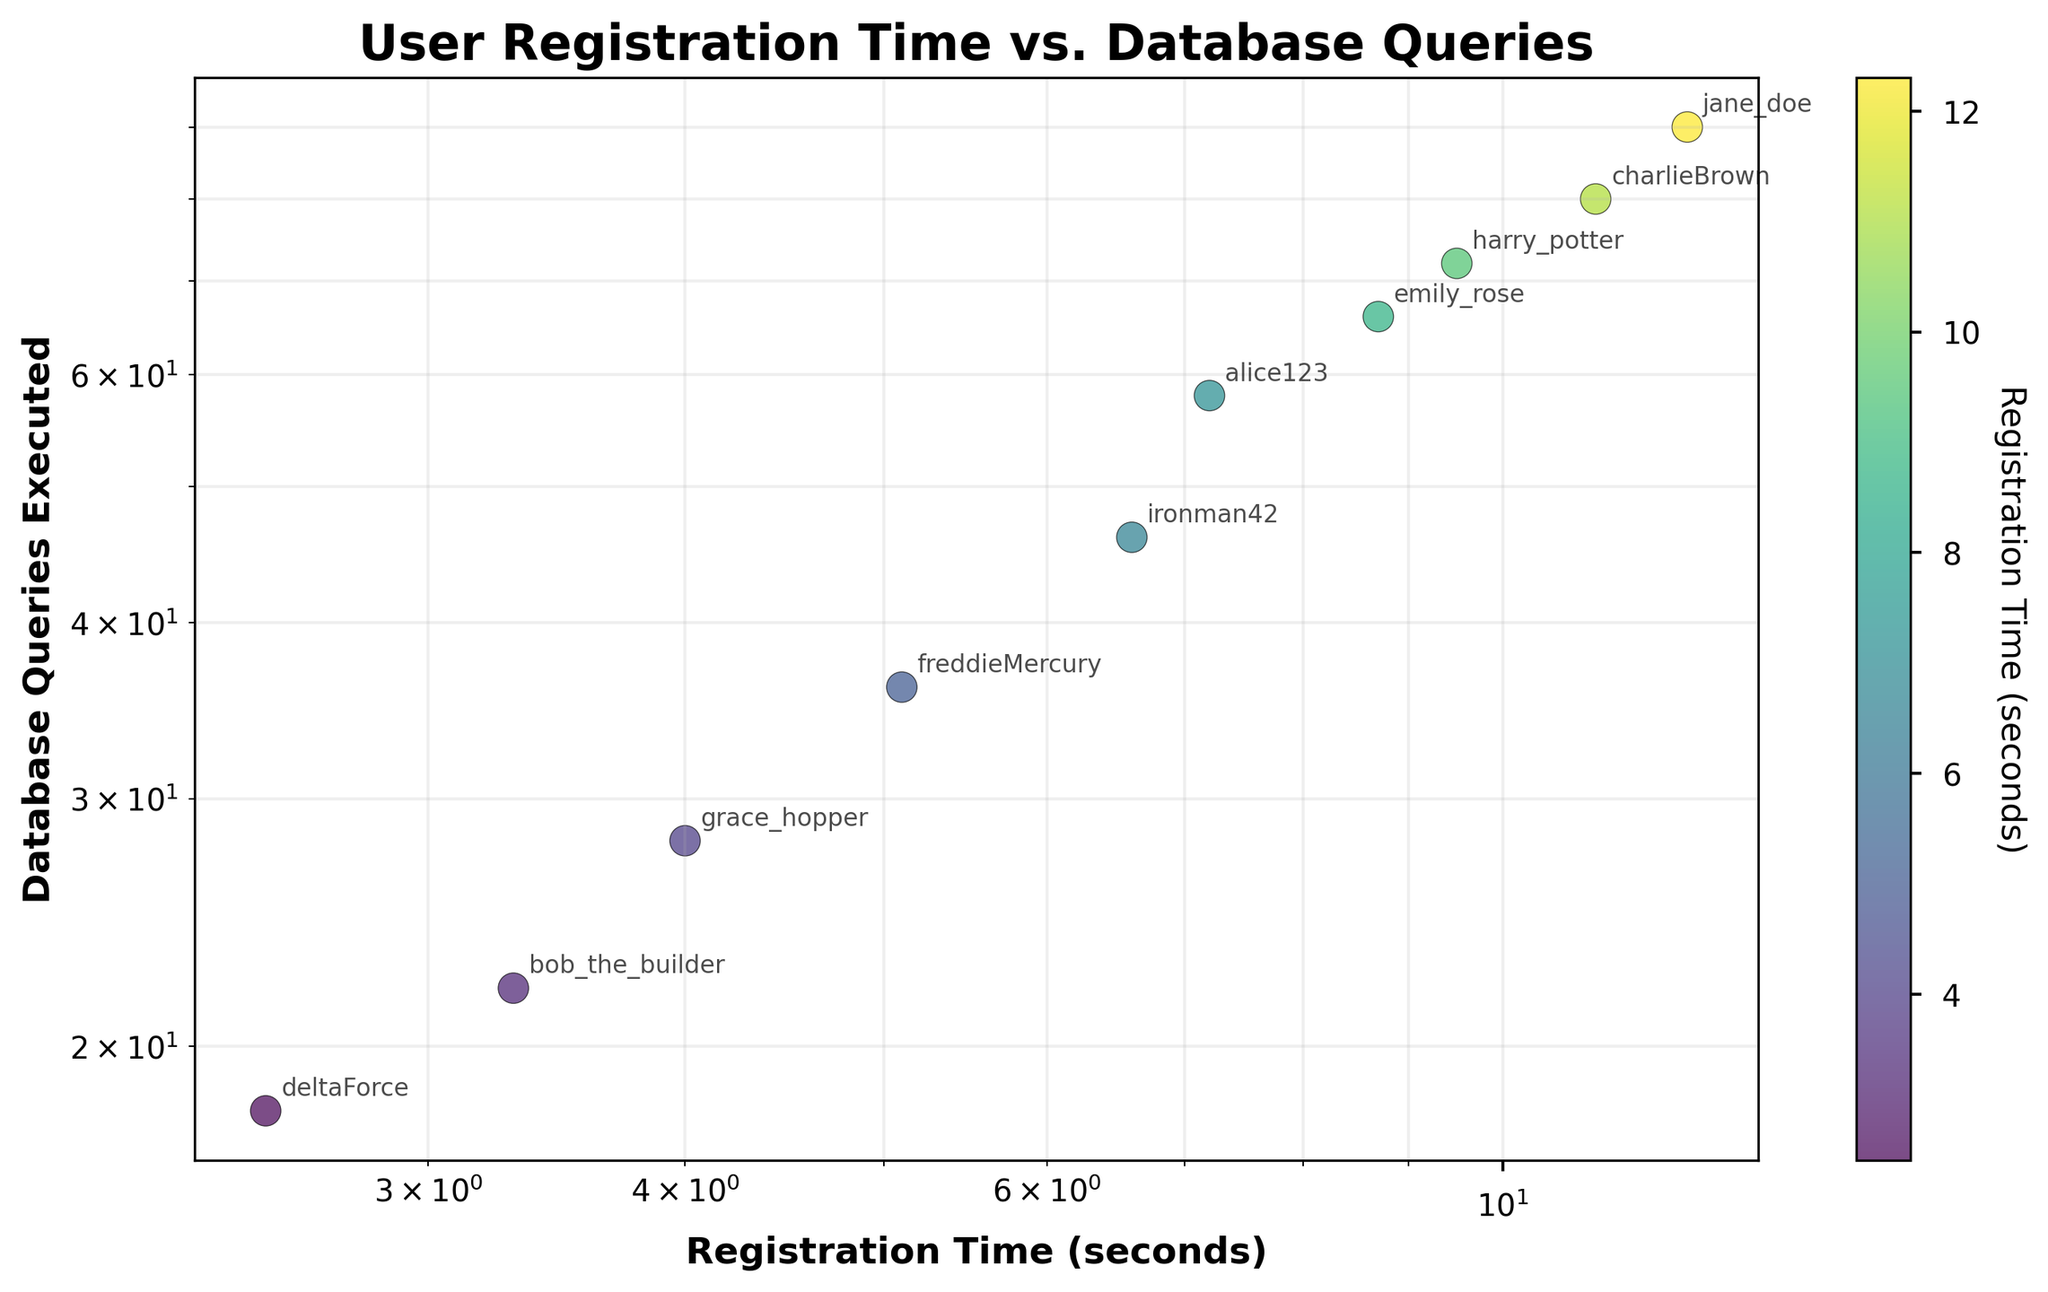What is the title of the plot? The title of the plot is usually displayed at the top center and provides a brief description of what the plot is about. In this figure, the title is directly related to the data being visualized.
Answer: User Registration Time vs. Database Queries How many data points are represented in the plot? Each data point corresponds to a user, and we can count the number of points displayed on the scatter plot to determine the total number of data points. Observing the plot, we count the total number of annotated usernames.
Answer: 10 How is the color of data points determined? The color of the data points is determined by the "Registration Time (seconds)", with a color bar indicating this on the side of the plot. Each point's color represents its registration time.
Answer: Registration Time (seconds) Which user has executed the most database queries? By looking at the vertical axis representing "Database Queries Executed" and identifying the point with the highest position, we can determine which user has executed the most queries. Observing the plot, this user is annotated.
Answer: jane_doe What is the range of registration times shown on the x-axis? The x-axis represents "Registration Time (seconds)" on a logarithmic scale. By examining the plot, especially the x-axis scale, we can determine the minimum and maximum values.
Answer: 2.5 to 12.3 seconds Compare the users "bob_the_builder" and "deltaForce" in terms of database queries executed. Which one has more queries? To find the user with more database queries, compare their vertical positions. "bob_the_builder" is at a higher position on the y-axis than "deltaForce".
Answer: bob_the_builder What is the average number of database queries executed by all users? We need to sum the database queries of all users and divide by the total number of users. Observing the y-values for each point: (58 + 22 + 80 + 18 + 66 + 36 + 28 + 72 + 46 + 90) / 10.
Answer: 51.6 Is there a correlation between registration time and the number of database queries executed? By observing the overall trend in the scatter plot, we can determine if there is a positive or negative correlation, or no correlation. A general visual examination can help identify the trend.
Answer: Positive correlation Which user has the shortest registration time? By looking at the horizontal axis representing "Registration Time (seconds)" and identifying the point closest to the leftmost side, this user's annotation can be read.
Answer: deltaForce How does the annotation help in interpreting the plot? Annotations provide direct labeling of the data points with usernames, making it easier to identify specific users and correlate them with their registration times and database queries. This is useful for quickly pinpointing particular data points of interest.
Answer: Identifies specific users and their data 